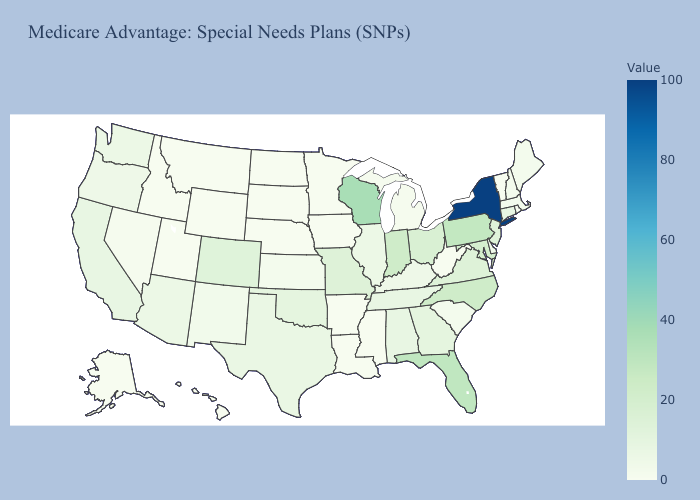Which states have the lowest value in the USA?
Give a very brief answer. Alaska, Arkansas, Hawaii, Iowa, Idaho, Louisiana, Minnesota, Mississippi, Montana, North Dakota, Nebraska, Rhode Island, South Dakota, Utah, Vermont, West Virginia, Wyoming. Which states have the highest value in the USA?
Quick response, please. New York. Which states have the lowest value in the West?
Short answer required. Alaska, Hawaii, Idaho, Montana, Utah, Wyoming. Which states hav the highest value in the MidWest?
Quick response, please. Wisconsin. 